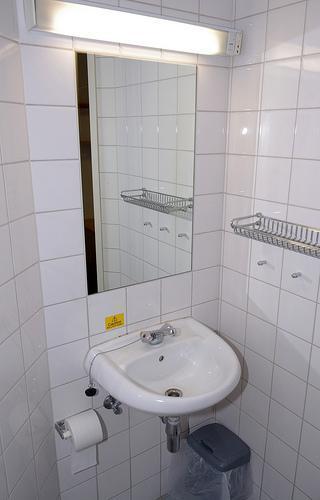How many lights?
Give a very brief answer. 1. 